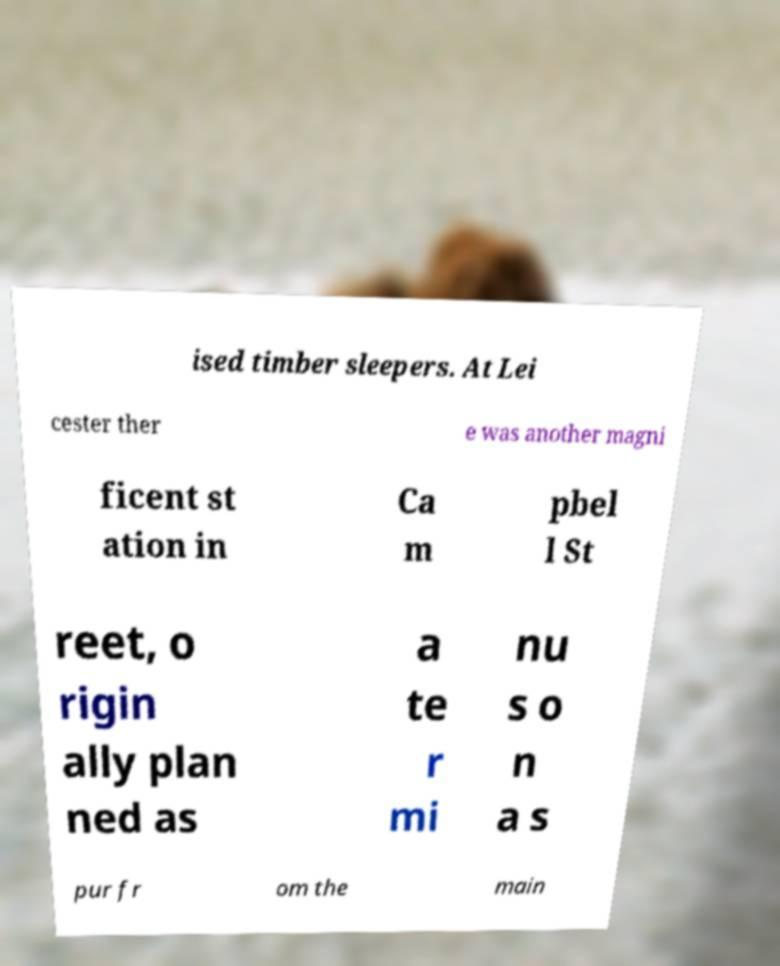I need the written content from this picture converted into text. Can you do that? ised timber sleepers. At Lei cester ther e was another magni ficent st ation in Ca m pbel l St reet, o rigin ally plan ned as a te r mi nu s o n a s pur fr om the main 